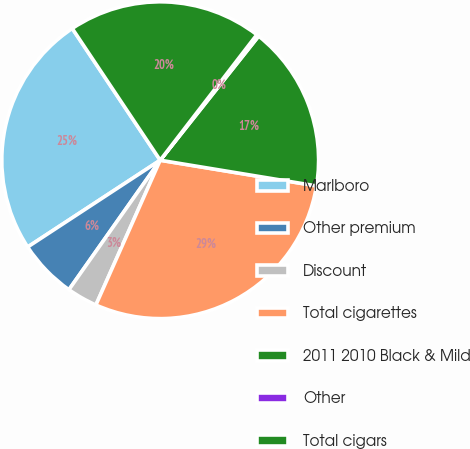Convert chart to OTSL. <chart><loc_0><loc_0><loc_500><loc_500><pie_chart><fcel>Marlboro<fcel>Other premium<fcel>Discount<fcel>Total cigarettes<fcel>2011 2010 Black & Mild<fcel>Other<fcel>Total cigars<nl><fcel>24.86%<fcel>6.0%<fcel>3.12%<fcel>29.06%<fcel>16.92%<fcel>0.23%<fcel>19.81%<nl></chart> 